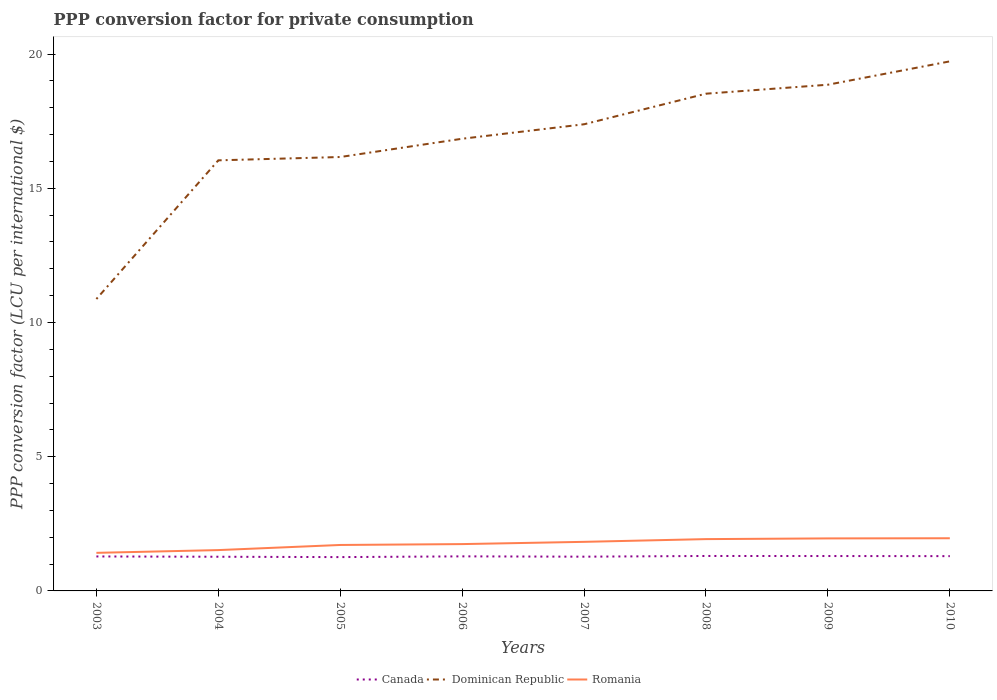How many different coloured lines are there?
Your response must be concise. 3. Across all years, what is the maximum PPP conversion factor for private consumption in Romania?
Provide a succinct answer. 1.42. What is the total PPP conversion factor for private consumption in Romania in the graph?
Keep it short and to the point. -0.33. What is the difference between the highest and the second highest PPP conversion factor for private consumption in Dominican Republic?
Provide a short and direct response. 8.85. What is the difference between the highest and the lowest PPP conversion factor for private consumption in Romania?
Your response must be concise. 4. What is the difference between two consecutive major ticks on the Y-axis?
Your answer should be compact. 5. Does the graph contain grids?
Ensure brevity in your answer.  No. How many legend labels are there?
Your answer should be very brief. 3. What is the title of the graph?
Make the answer very short. PPP conversion factor for private consumption. What is the label or title of the X-axis?
Provide a succinct answer. Years. What is the label or title of the Y-axis?
Offer a very short reply. PPP conversion factor (LCU per international $). What is the PPP conversion factor (LCU per international $) in Canada in 2003?
Give a very brief answer. 1.28. What is the PPP conversion factor (LCU per international $) in Dominican Republic in 2003?
Your answer should be compact. 10.87. What is the PPP conversion factor (LCU per international $) of Romania in 2003?
Ensure brevity in your answer.  1.42. What is the PPP conversion factor (LCU per international $) in Canada in 2004?
Your answer should be very brief. 1.27. What is the PPP conversion factor (LCU per international $) of Dominican Republic in 2004?
Ensure brevity in your answer.  16.04. What is the PPP conversion factor (LCU per international $) in Romania in 2004?
Provide a short and direct response. 1.52. What is the PPP conversion factor (LCU per international $) in Canada in 2005?
Your answer should be very brief. 1.26. What is the PPP conversion factor (LCU per international $) in Dominican Republic in 2005?
Your response must be concise. 16.16. What is the PPP conversion factor (LCU per international $) in Romania in 2005?
Give a very brief answer. 1.71. What is the PPP conversion factor (LCU per international $) in Canada in 2006?
Make the answer very short. 1.29. What is the PPP conversion factor (LCU per international $) in Dominican Republic in 2006?
Your answer should be compact. 16.84. What is the PPP conversion factor (LCU per international $) of Romania in 2006?
Offer a terse response. 1.74. What is the PPP conversion factor (LCU per international $) in Canada in 2007?
Offer a terse response. 1.28. What is the PPP conversion factor (LCU per international $) in Dominican Republic in 2007?
Give a very brief answer. 17.38. What is the PPP conversion factor (LCU per international $) of Romania in 2007?
Your answer should be compact. 1.83. What is the PPP conversion factor (LCU per international $) of Canada in 2008?
Your answer should be compact. 1.3. What is the PPP conversion factor (LCU per international $) of Dominican Republic in 2008?
Offer a terse response. 18.52. What is the PPP conversion factor (LCU per international $) in Romania in 2008?
Ensure brevity in your answer.  1.93. What is the PPP conversion factor (LCU per international $) in Canada in 2009?
Provide a succinct answer. 1.3. What is the PPP conversion factor (LCU per international $) in Dominican Republic in 2009?
Give a very brief answer. 18.86. What is the PPP conversion factor (LCU per international $) of Romania in 2009?
Your answer should be very brief. 1.96. What is the PPP conversion factor (LCU per international $) of Canada in 2010?
Keep it short and to the point. 1.3. What is the PPP conversion factor (LCU per international $) of Dominican Republic in 2010?
Give a very brief answer. 19.73. What is the PPP conversion factor (LCU per international $) in Romania in 2010?
Offer a terse response. 1.96. Across all years, what is the maximum PPP conversion factor (LCU per international $) of Canada?
Offer a terse response. 1.3. Across all years, what is the maximum PPP conversion factor (LCU per international $) of Dominican Republic?
Your response must be concise. 19.73. Across all years, what is the maximum PPP conversion factor (LCU per international $) in Romania?
Give a very brief answer. 1.96. Across all years, what is the minimum PPP conversion factor (LCU per international $) of Canada?
Your answer should be very brief. 1.26. Across all years, what is the minimum PPP conversion factor (LCU per international $) in Dominican Republic?
Keep it short and to the point. 10.87. Across all years, what is the minimum PPP conversion factor (LCU per international $) of Romania?
Your answer should be very brief. 1.42. What is the total PPP conversion factor (LCU per international $) in Canada in the graph?
Provide a succinct answer. 10.28. What is the total PPP conversion factor (LCU per international $) of Dominican Republic in the graph?
Provide a short and direct response. 134.41. What is the total PPP conversion factor (LCU per international $) in Romania in the graph?
Offer a very short reply. 14.07. What is the difference between the PPP conversion factor (LCU per international $) of Canada in 2003 and that in 2004?
Your answer should be compact. 0.01. What is the difference between the PPP conversion factor (LCU per international $) in Dominican Republic in 2003 and that in 2004?
Provide a succinct answer. -5.17. What is the difference between the PPP conversion factor (LCU per international $) in Romania in 2003 and that in 2004?
Your answer should be very brief. -0.1. What is the difference between the PPP conversion factor (LCU per international $) in Canada in 2003 and that in 2005?
Give a very brief answer. 0.02. What is the difference between the PPP conversion factor (LCU per international $) of Dominican Republic in 2003 and that in 2005?
Offer a terse response. -5.29. What is the difference between the PPP conversion factor (LCU per international $) of Romania in 2003 and that in 2005?
Give a very brief answer. -0.29. What is the difference between the PPP conversion factor (LCU per international $) of Canada in 2003 and that in 2006?
Ensure brevity in your answer.  -0. What is the difference between the PPP conversion factor (LCU per international $) in Dominican Republic in 2003 and that in 2006?
Make the answer very short. -5.97. What is the difference between the PPP conversion factor (LCU per international $) of Romania in 2003 and that in 2006?
Offer a very short reply. -0.33. What is the difference between the PPP conversion factor (LCU per international $) in Canada in 2003 and that in 2007?
Provide a short and direct response. 0.01. What is the difference between the PPP conversion factor (LCU per international $) in Dominican Republic in 2003 and that in 2007?
Offer a terse response. -6.51. What is the difference between the PPP conversion factor (LCU per international $) in Romania in 2003 and that in 2007?
Your answer should be very brief. -0.41. What is the difference between the PPP conversion factor (LCU per international $) of Canada in 2003 and that in 2008?
Provide a short and direct response. -0.02. What is the difference between the PPP conversion factor (LCU per international $) of Dominican Republic in 2003 and that in 2008?
Make the answer very short. -7.65. What is the difference between the PPP conversion factor (LCU per international $) in Romania in 2003 and that in 2008?
Offer a very short reply. -0.51. What is the difference between the PPP conversion factor (LCU per international $) of Canada in 2003 and that in 2009?
Provide a succinct answer. -0.02. What is the difference between the PPP conversion factor (LCU per international $) in Dominican Republic in 2003 and that in 2009?
Keep it short and to the point. -7.98. What is the difference between the PPP conversion factor (LCU per international $) of Romania in 2003 and that in 2009?
Offer a terse response. -0.54. What is the difference between the PPP conversion factor (LCU per international $) in Canada in 2003 and that in 2010?
Your response must be concise. -0.01. What is the difference between the PPP conversion factor (LCU per international $) of Dominican Republic in 2003 and that in 2010?
Offer a terse response. -8.85. What is the difference between the PPP conversion factor (LCU per international $) of Romania in 2003 and that in 2010?
Offer a terse response. -0.54. What is the difference between the PPP conversion factor (LCU per international $) of Canada in 2004 and that in 2005?
Your answer should be very brief. 0.01. What is the difference between the PPP conversion factor (LCU per international $) of Dominican Republic in 2004 and that in 2005?
Your answer should be very brief. -0.12. What is the difference between the PPP conversion factor (LCU per international $) of Romania in 2004 and that in 2005?
Offer a terse response. -0.19. What is the difference between the PPP conversion factor (LCU per international $) in Canada in 2004 and that in 2006?
Your answer should be very brief. -0.01. What is the difference between the PPP conversion factor (LCU per international $) of Dominican Republic in 2004 and that in 2006?
Offer a terse response. -0.8. What is the difference between the PPP conversion factor (LCU per international $) in Romania in 2004 and that in 2006?
Provide a succinct answer. -0.22. What is the difference between the PPP conversion factor (LCU per international $) of Canada in 2004 and that in 2007?
Give a very brief answer. -0. What is the difference between the PPP conversion factor (LCU per international $) in Dominican Republic in 2004 and that in 2007?
Make the answer very short. -1.34. What is the difference between the PPP conversion factor (LCU per international $) in Romania in 2004 and that in 2007?
Your answer should be very brief. -0.31. What is the difference between the PPP conversion factor (LCU per international $) in Canada in 2004 and that in 2008?
Ensure brevity in your answer.  -0.03. What is the difference between the PPP conversion factor (LCU per international $) of Dominican Republic in 2004 and that in 2008?
Provide a succinct answer. -2.48. What is the difference between the PPP conversion factor (LCU per international $) in Romania in 2004 and that in 2008?
Provide a short and direct response. -0.41. What is the difference between the PPP conversion factor (LCU per international $) of Canada in 2004 and that in 2009?
Your answer should be very brief. -0.03. What is the difference between the PPP conversion factor (LCU per international $) of Dominican Republic in 2004 and that in 2009?
Provide a short and direct response. -2.82. What is the difference between the PPP conversion factor (LCU per international $) of Romania in 2004 and that in 2009?
Provide a succinct answer. -0.44. What is the difference between the PPP conversion factor (LCU per international $) in Canada in 2004 and that in 2010?
Make the answer very short. -0.02. What is the difference between the PPP conversion factor (LCU per international $) in Dominican Republic in 2004 and that in 2010?
Offer a terse response. -3.69. What is the difference between the PPP conversion factor (LCU per international $) in Romania in 2004 and that in 2010?
Offer a very short reply. -0.44. What is the difference between the PPP conversion factor (LCU per international $) in Canada in 2005 and that in 2006?
Your response must be concise. -0.03. What is the difference between the PPP conversion factor (LCU per international $) in Dominican Republic in 2005 and that in 2006?
Offer a very short reply. -0.68. What is the difference between the PPP conversion factor (LCU per international $) in Romania in 2005 and that in 2006?
Your answer should be very brief. -0.03. What is the difference between the PPP conversion factor (LCU per international $) in Canada in 2005 and that in 2007?
Keep it short and to the point. -0.02. What is the difference between the PPP conversion factor (LCU per international $) of Dominican Republic in 2005 and that in 2007?
Provide a short and direct response. -1.22. What is the difference between the PPP conversion factor (LCU per international $) in Romania in 2005 and that in 2007?
Provide a short and direct response. -0.12. What is the difference between the PPP conversion factor (LCU per international $) in Canada in 2005 and that in 2008?
Ensure brevity in your answer.  -0.04. What is the difference between the PPP conversion factor (LCU per international $) in Dominican Republic in 2005 and that in 2008?
Offer a terse response. -2.36. What is the difference between the PPP conversion factor (LCU per international $) in Romania in 2005 and that in 2008?
Make the answer very short. -0.22. What is the difference between the PPP conversion factor (LCU per international $) in Canada in 2005 and that in 2009?
Your answer should be compact. -0.04. What is the difference between the PPP conversion factor (LCU per international $) of Dominican Republic in 2005 and that in 2009?
Keep it short and to the point. -2.69. What is the difference between the PPP conversion factor (LCU per international $) of Romania in 2005 and that in 2009?
Your answer should be very brief. -0.24. What is the difference between the PPP conversion factor (LCU per international $) in Canada in 2005 and that in 2010?
Your answer should be compact. -0.04. What is the difference between the PPP conversion factor (LCU per international $) in Dominican Republic in 2005 and that in 2010?
Your response must be concise. -3.56. What is the difference between the PPP conversion factor (LCU per international $) in Romania in 2005 and that in 2010?
Your answer should be compact. -0.25. What is the difference between the PPP conversion factor (LCU per international $) in Canada in 2006 and that in 2007?
Your answer should be very brief. 0.01. What is the difference between the PPP conversion factor (LCU per international $) of Dominican Republic in 2006 and that in 2007?
Your response must be concise. -0.54. What is the difference between the PPP conversion factor (LCU per international $) in Romania in 2006 and that in 2007?
Ensure brevity in your answer.  -0.08. What is the difference between the PPP conversion factor (LCU per international $) in Canada in 2006 and that in 2008?
Make the answer very short. -0.01. What is the difference between the PPP conversion factor (LCU per international $) in Dominican Republic in 2006 and that in 2008?
Provide a succinct answer. -1.68. What is the difference between the PPP conversion factor (LCU per international $) in Romania in 2006 and that in 2008?
Make the answer very short. -0.19. What is the difference between the PPP conversion factor (LCU per international $) of Canada in 2006 and that in 2009?
Give a very brief answer. -0.01. What is the difference between the PPP conversion factor (LCU per international $) in Dominican Republic in 2006 and that in 2009?
Provide a succinct answer. -2.01. What is the difference between the PPP conversion factor (LCU per international $) in Romania in 2006 and that in 2009?
Offer a very short reply. -0.21. What is the difference between the PPP conversion factor (LCU per international $) of Canada in 2006 and that in 2010?
Ensure brevity in your answer.  -0.01. What is the difference between the PPP conversion factor (LCU per international $) in Dominican Republic in 2006 and that in 2010?
Your answer should be compact. -2.88. What is the difference between the PPP conversion factor (LCU per international $) in Romania in 2006 and that in 2010?
Offer a very short reply. -0.22. What is the difference between the PPP conversion factor (LCU per international $) of Canada in 2007 and that in 2008?
Your response must be concise. -0.03. What is the difference between the PPP conversion factor (LCU per international $) in Dominican Republic in 2007 and that in 2008?
Your answer should be compact. -1.14. What is the difference between the PPP conversion factor (LCU per international $) in Romania in 2007 and that in 2008?
Provide a succinct answer. -0.1. What is the difference between the PPP conversion factor (LCU per international $) of Canada in 2007 and that in 2009?
Give a very brief answer. -0.02. What is the difference between the PPP conversion factor (LCU per international $) of Dominican Republic in 2007 and that in 2009?
Your response must be concise. -1.47. What is the difference between the PPP conversion factor (LCU per international $) of Romania in 2007 and that in 2009?
Your response must be concise. -0.13. What is the difference between the PPP conversion factor (LCU per international $) of Canada in 2007 and that in 2010?
Your response must be concise. -0.02. What is the difference between the PPP conversion factor (LCU per international $) in Dominican Republic in 2007 and that in 2010?
Provide a short and direct response. -2.34. What is the difference between the PPP conversion factor (LCU per international $) of Romania in 2007 and that in 2010?
Keep it short and to the point. -0.13. What is the difference between the PPP conversion factor (LCU per international $) of Canada in 2008 and that in 2009?
Keep it short and to the point. 0. What is the difference between the PPP conversion factor (LCU per international $) of Dominican Republic in 2008 and that in 2009?
Give a very brief answer. -0.33. What is the difference between the PPP conversion factor (LCU per international $) of Romania in 2008 and that in 2009?
Offer a terse response. -0.03. What is the difference between the PPP conversion factor (LCU per international $) in Canada in 2008 and that in 2010?
Provide a short and direct response. 0.01. What is the difference between the PPP conversion factor (LCU per international $) of Dominican Republic in 2008 and that in 2010?
Offer a very short reply. -1.2. What is the difference between the PPP conversion factor (LCU per international $) in Romania in 2008 and that in 2010?
Make the answer very short. -0.03. What is the difference between the PPP conversion factor (LCU per international $) of Canada in 2009 and that in 2010?
Provide a short and direct response. 0. What is the difference between the PPP conversion factor (LCU per international $) in Dominican Republic in 2009 and that in 2010?
Keep it short and to the point. -0.87. What is the difference between the PPP conversion factor (LCU per international $) of Romania in 2009 and that in 2010?
Keep it short and to the point. -0.01. What is the difference between the PPP conversion factor (LCU per international $) of Canada in 2003 and the PPP conversion factor (LCU per international $) of Dominican Republic in 2004?
Keep it short and to the point. -14.76. What is the difference between the PPP conversion factor (LCU per international $) of Canada in 2003 and the PPP conversion factor (LCU per international $) of Romania in 2004?
Provide a short and direct response. -0.24. What is the difference between the PPP conversion factor (LCU per international $) of Dominican Republic in 2003 and the PPP conversion factor (LCU per international $) of Romania in 2004?
Keep it short and to the point. 9.35. What is the difference between the PPP conversion factor (LCU per international $) of Canada in 2003 and the PPP conversion factor (LCU per international $) of Dominican Republic in 2005?
Your response must be concise. -14.88. What is the difference between the PPP conversion factor (LCU per international $) in Canada in 2003 and the PPP conversion factor (LCU per international $) in Romania in 2005?
Provide a short and direct response. -0.43. What is the difference between the PPP conversion factor (LCU per international $) of Dominican Republic in 2003 and the PPP conversion factor (LCU per international $) of Romania in 2005?
Make the answer very short. 9.16. What is the difference between the PPP conversion factor (LCU per international $) in Canada in 2003 and the PPP conversion factor (LCU per international $) in Dominican Republic in 2006?
Provide a succinct answer. -15.56. What is the difference between the PPP conversion factor (LCU per international $) of Canada in 2003 and the PPP conversion factor (LCU per international $) of Romania in 2006?
Keep it short and to the point. -0.46. What is the difference between the PPP conversion factor (LCU per international $) in Dominican Republic in 2003 and the PPP conversion factor (LCU per international $) in Romania in 2006?
Give a very brief answer. 9.13. What is the difference between the PPP conversion factor (LCU per international $) in Canada in 2003 and the PPP conversion factor (LCU per international $) in Dominican Republic in 2007?
Give a very brief answer. -16.1. What is the difference between the PPP conversion factor (LCU per international $) in Canada in 2003 and the PPP conversion factor (LCU per international $) in Romania in 2007?
Your response must be concise. -0.54. What is the difference between the PPP conversion factor (LCU per international $) in Dominican Republic in 2003 and the PPP conversion factor (LCU per international $) in Romania in 2007?
Provide a short and direct response. 9.05. What is the difference between the PPP conversion factor (LCU per international $) in Canada in 2003 and the PPP conversion factor (LCU per international $) in Dominican Republic in 2008?
Ensure brevity in your answer.  -17.24. What is the difference between the PPP conversion factor (LCU per international $) in Canada in 2003 and the PPP conversion factor (LCU per international $) in Romania in 2008?
Your answer should be compact. -0.65. What is the difference between the PPP conversion factor (LCU per international $) in Dominican Republic in 2003 and the PPP conversion factor (LCU per international $) in Romania in 2008?
Offer a very short reply. 8.94. What is the difference between the PPP conversion factor (LCU per international $) in Canada in 2003 and the PPP conversion factor (LCU per international $) in Dominican Republic in 2009?
Give a very brief answer. -17.57. What is the difference between the PPP conversion factor (LCU per international $) in Canada in 2003 and the PPP conversion factor (LCU per international $) in Romania in 2009?
Ensure brevity in your answer.  -0.67. What is the difference between the PPP conversion factor (LCU per international $) in Dominican Republic in 2003 and the PPP conversion factor (LCU per international $) in Romania in 2009?
Offer a very short reply. 8.92. What is the difference between the PPP conversion factor (LCU per international $) in Canada in 2003 and the PPP conversion factor (LCU per international $) in Dominican Republic in 2010?
Provide a short and direct response. -18.44. What is the difference between the PPP conversion factor (LCU per international $) in Canada in 2003 and the PPP conversion factor (LCU per international $) in Romania in 2010?
Offer a very short reply. -0.68. What is the difference between the PPP conversion factor (LCU per international $) in Dominican Republic in 2003 and the PPP conversion factor (LCU per international $) in Romania in 2010?
Your response must be concise. 8.91. What is the difference between the PPP conversion factor (LCU per international $) in Canada in 2004 and the PPP conversion factor (LCU per international $) in Dominican Republic in 2005?
Provide a short and direct response. -14.89. What is the difference between the PPP conversion factor (LCU per international $) of Canada in 2004 and the PPP conversion factor (LCU per international $) of Romania in 2005?
Ensure brevity in your answer.  -0.44. What is the difference between the PPP conversion factor (LCU per international $) of Dominican Republic in 2004 and the PPP conversion factor (LCU per international $) of Romania in 2005?
Make the answer very short. 14.33. What is the difference between the PPP conversion factor (LCU per international $) in Canada in 2004 and the PPP conversion factor (LCU per international $) in Dominican Republic in 2006?
Your answer should be very brief. -15.57. What is the difference between the PPP conversion factor (LCU per international $) in Canada in 2004 and the PPP conversion factor (LCU per international $) in Romania in 2006?
Keep it short and to the point. -0.47. What is the difference between the PPP conversion factor (LCU per international $) in Dominican Republic in 2004 and the PPP conversion factor (LCU per international $) in Romania in 2006?
Your response must be concise. 14.3. What is the difference between the PPP conversion factor (LCU per international $) of Canada in 2004 and the PPP conversion factor (LCU per international $) of Dominican Republic in 2007?
Your response must be concise. -16.11. What is the difference between the PPP conversion factor (LCU per international $) of Canada in 2004 and the PPP conversion factor (LCU per international $) of Romania in 2007?
Your response must be concise. -0.55. What is the difference between the PPP conversion factor (LCU per international $) of Dominican Republic in 2004 and the PPP conversion factor (LCU per international $) of Romania in 2007?
Give a very brief answer. 14.21. What is the difference between the PPP conversion factor (LCU per international $) in Canada in 2004 and the PPP conversion factor (LCU per international $) in Dominican Republic in 2008?
Keep it short and to the point. -17.25. What is the difference between the PPP conversion factor (LCU per international $) in Canada in 2004 and the PPP conversion factor (LCU per international $) in Romania in 2008?
Your answer should be very brief. -0.66. What is the difference between the PPP conversion factor (LCU per international $) in Dominican Republic in 2004 and the PPP conversion factor (LCU per international $) in Romania in 2008?
Your response must be concise. 14.11. What is the difference between the PPP conversion factor (LCU per international $) of Canada in 2004 and the PPP conversion factor (LCU per international $) of Dominican Republic in 2009?
Provide a short and direct response. -17.58. What is the difference between the PPP conversion factor (LCU per international $) in Canada in 2004 and the PPP conversion factor (LCU per international $) in Romania in 2009?
Provide a short and direct response. -0.68. What is the difference between the PPP conversion factor (LCU per international $) in Dominican Republic in 2004 and the PPP conversion factor (LCU per international $) in Romania in 2009?
Provide a succinct answer. 14.08. What is the difference between the PPP conversion factor (LCU per international $) in Canada in 2004 and the PPP conversion factor (LCU per international $) in Dominican Republic in 2010?
Your answer should be very brief. -18.45. What is the difference between the PPP conversion factor (LCU per international $) of Canada in 2004 and the PPP conversion factor (LCU per international $) of Romania in 2010?
Your response must be concise. -0.69. What is the difference between the PPP conversion factor (LCU per international $) of Dominican Republic in 2004 and the PPP conversion factor (LCU per international $) of Romania in 2010?
Give a very brief answer. 14.08. What is the difference between the PPP conversion factor (LCU per international $) in Canada in 2005 and the PPP conversion factor (LCU per international $) in Dominican Republic in 2006?
Offer a very short reply. -15.58. What is the difference between the PPP conversion factor (LCU per international $) of Canada in 2005 and the PPP conversion factor (LCU per international $) of Romania in 2006?
Offer a very short reply. -0.48. What is the difference between the PPP conversion factor (LCU per international $) of Dominican Republic in 2005 and the PPP conversion factor (LCU per international $) of Romania in 2006?
Keep it short and to the point. 14.42. What is the difference between the PPP conversion factor (LCU per international $) in Canada in 2005 and the PPP conversion factor (LCU per international $) in Dominican Republic in 2007?
Your answer should be compact. -16.12. What is the difference between the PPP conversion factor (LCU per international $) of Canada in 2005 and the PPP conversion factor (LCU per international $) of Romania in 2007?
Give a very brief answer. -0.57. What is the difference between the PPP conversion factor (LCU per international $) in Dominican Republic in 2005 and the PPP conversion factor (LCU per international $) in Romania in 2007?
Provide a short and direct response. 14.34. What is the difference between the PPP conversion factor (LCU per international $) in Canada in 2005 and the PPP conversion factor (LCU per international $) in Dominican Republic in 2008?
Offer a terse response. -17.26. What is the difference between the PPP conversion factor (LCU per international $) of Canada in 2005 and the PPP conversion factor (LCU per international $) of Romania in 2008?
Give a very brief answer. -0.67. What is the difference between the PPP conversion factor (LCU per international $) of Dominican Republic in 2005 and the PPP conversion factor (LCU per international $) of Romania in 2008?
Your answer should be very brief. 14.23. What is the difference between the PPP conversion factor (LCU per international $) of Canada in 2005 and the PPP conversion factor (LCU per international $) of Dominican Republic in 2009?
Ensure brevity in your answer.  -17.6. What is the difference between the PPP conversion factor (LCU per international $) in Canada in 2005 and the PPP conversion factor (LCU per international $) in Romania in 2009?
Your answer should be compact. -0.7. What is the difference between the PPP conversion factor (LCU per international $) in Dominican Republic in 2005 and the PPP conversion factor (LCU per international $) in Romania in 2009?
Your answer should be compact. 14.21. What is the difference between the PPP conversion factor (LCU per international $) in Canada in 2005 and the PPP conversion factor (LCU per international $) in Dominican Republic in 2010?
Your response must be concise. -18.47. What is the difference between the PPP conversion factor (LCU per international $) in Canada in 2005 and the PPP conversion factor (LCU per international $) in Romania in 2010?
Offer a terse response. -0.7. What is the difference between the PPP conversion factor (LCU per international $) of Dominican Republic in 2005 and the PPP conversion factor (LCU per international $) of Romania in 2010?
Provide a short and direct response. 14.2. What is the difference between the PPP conversion factor (LCU per international $) in Canada in 2006 and the PPP conversion factor (LCU per international $) in Dominican Republic in 2007?
Your answer should be very brief. -16.1. What is the difference between the PPP conversion factor (LCU per international $) in Canada in 2006 and the PPP conversion factor (LCU per international $) in Romania in 2007?
Provide a short and direct response. -0.54. What is the difference between the PPP conversion factor (LCU per international $) of Dominican Republic in 2006 and the PPP conversion factor (LCU per international $) of Romania in 2007?
Make the answer very short. 15.02. What is the difference between the PPP conversion factor (LCU per international $) of Canada in 2006 and the PPP conversion factor (LCU per international $) of Dominican Republic in 2008?
Make the answer very short. -17.24. What is the difference between the PPP conversion factor (LCU per international $) of Canada in 2006 and the PPP conversion factor (LCU per international $) of Romania in 2008?
Offer a terse response. -0.64. What is the difference between the PPP conversion factor (LCU per international $) in Dominican Republic in 2006 and the PPP conversion factor (LCU per international $) in Romania in 2008?
Your response must be concise. 14.91. What is the difference between the PPP conversion factor (LCU per international $) of Canada in 2006 and the PPP conversion factor (LCU per international $) of Dominican Republic in 2009?
Make the answer very short. -17.57. What is the difference between the PPP conversion factor (LCU per international $) in Canada in 2006 and the PPP conversion factor (LCU per international $) in Romania in 2009?
Provide a short and direct response. -0.67. What is the difference between the PPP conversion factor (LCU per international $) of Dominican Republic in 2006 and the PPP conversion factor (LCU per international $) of Romania in 2009?
Provide a succinct answer. 14.89. What is the difference between the PPP conversion factor (LCU per international $) in Canada in 2006 and the PPP conversion factor (LCU per international $) in Dominican Republic in 2010?
Provide a succinct answer. -18.44. What is the difference between the PPP conversion factor (LCU per international $) in Canada in 2006 and the PPP conversion factor (LCU per international $) in Romania in 2010?
Give a very brief answer. -0.67. What is the difference between the PPP conversion factor (LCU per international $) in Dominican Republic in 2006 and the PPP conversion factor (LCU per international $) in Romania in 2010?
Ensure brevity in your answer.  14.88. What is the difference between the PPP conversion factor (LCU per international $) of Canada in 2007 and the PPP conversion factor (LCU per international $) of Dominican Republic in 2008?
Your answer should be compact. -17.25. What is the difference between the PPP conversion factor (LCU per international $) in Canada in 2007 and the PPP conversion factor (LCU per international $) in Romania in 2008?
Your response must be concise. -0.65. What is the difference between the PPP conversion factor (LCU per international $) of Dominican Republic in 2007 and the PPP conversion factor (LCU per international $) of Romania in 2008?
Your response must be concise. 15.45. What is the difference between the PPP conversion factor (LCU per international $) of Canada in 2007 and the PPP conversion factor (LCU per international $) of Dominican Republic in 2009?
Make the answer very short. -17.58. What is the difference between the PPP conversion factor (LCU per international $) of Canada in 2007 and the PPP conversion factor (LCU per international $) of Romania in 2009?
Offer a terse response. -0.68. What is the difference between the PPP conversion factor (LCU per international $) of Dominican Republic in 2007 and the PPP conversion factor (LCU per international $) of Romania in 2009?
Offer a terse response. 15.43. What is the difference between the PPP conversion factor (LCU per international $) in Canada in 2007 and the PPP conversion factor (LCU per international $) in Dominican Republic in 2010?
Provide a succinct answer. -18.45. What is the difference between the PPP conversion factor (LCU per international $) of Canada in 2007 and the PPP conversion factor (LCU per international $) of Romania in 2010?
Your response must be concise. -0.69. What is the difference between the PPP conversion factor (LCU per international $) of Dominican Republic in 2007 and the PPP conversion factor (LCU per international $) of Romania in 2010?
Keep it short and to the point. 15.42. What is the difference between the PPP conversion factor (LCU per international $) in Canada in 2008 and the PPP conversion factor (LCU per international $) in Dominican Republic in 2009?
Your response must be concise. -17.55. What is the difference between the PPP conversion factor (LCU per international $) in Canada in 2008 and the PPP conversion factor (LCU per international $) in Romania in 2009?
Keep it short and to the point. -0.65. What is the difference between the PPP conversion factor (LCU per international $) in Dominican Republic in 2008 and the PPP conversion factor (LCU per international $) in Romania in 2009?
Provide a succinct answer. 16.57. What is the difference between the PPP conversion factor (LCU per international $) in Canada in 2008 and the PPP conversion factor (LCU per international $) in Dominican Republic in 2010?
Your response must be concise. -18.43. What is the difference between the PPP conversion factor (LCU per international $) of Canada in 2008 and the PPP conversion factor (LCU per international $) of Romania in 2010?
Offer a terse response. -0.66. What is the difference between the PPP conversion factor (LCU per international $) of Dominican Republic in 2008 and the PPP conversion factor (LCU per international $) of Romania in 2010?
Make the answer very short. 16.56. What is the difference between the PPP conversion factor (LCU per international $) in Canada in 2009 and the PPP conversion factor (LCU per international $) in Dominican Republic in 2010?
Offer a terse response. -18.43. What is the difference between the PPP conversion factor (LCU per international $) of Canada in 2009 and the PPP conversion factor (LCU per international $) of Romania in 2010?
Offer a very short reply. -0.66. What is the difference between the PPP conversion factor (LCU per international $) in Dominican Republic in 2009 and the PPP conversion factor (LCU per international $) in Romania in 2010?
Your response must be concise. 16.89. What is the average PPP conversion factor (LCU per international $) in Canada per year?
Make the answer very short. 1.28. What is the average PPP conversion factor (LCU per international $) of Dominican Republic per year?
Provide a succinct answer. 16.8. What is the average PPP conversion factor (LCU per international $) in Romania per year?
Keep it short and to the point. 1.76. In the year 2003, what is the difference between the PPP conversion factor (LCU per international $) of Canada and PPP conversion factor (LCU per international $) of Dominican Republic?
Ensure brevity in your answer.  -9.59. In the year 2003, what is the difference between the PPP conversion factor (LCU per international $) of Canada and PPP conversion factor (LCU per international $) of Romania?
Make the answer very short. -0.13. In the year 2003, what is the difference between the PPP conversion factor (LCU per international $) of Dominican Republic and PPP conversion factor (LCU per international $) of Romania?
Give a very brief answer. 9.46. In the year 2004, what is the difference between the PPP conversion factor (LCU per international $) in Canada and PPP conversion factor (LCU per international $) in Dominican Republic?
Make the answer very short. -14.77. In the year 2004, what is the difference between the PPP conversion factor (LCU per international $) of Canada and PPP conversion factor (LCU per international $) of Romania?
Your answer should be very brief. -0.25. In the year 2004, what is the difference between the PPP conversion factor (LCU per international $) of Dominican Republic and PPP conversion factor (LCU per international $) of Romania?
Your answer should be very brief. 14.52. In the year 2005, what is the difference between the PPP conversion factor (LCU per international $) of Canada and PPP conversion factor (LCU per international $) of Dominican Republic?
Offer a very short reply. -14.9. In the year 2005, what is the difference between the PPP conversion factor (LCU per international $) of Canada and PPP conversion factor (LCU per international $) of Romania?
Ensure brevity in your answer.  -0.45. In the year 2005, what is the difference between the PPP conversion factor (LCU per international $) in Dominican Republic and PPP conversion factor (LCU per international $) in Romania?
Offer a very short reply. 14.45. In the year 2006, what is the difference between the PPP conversion factor (LCU per international $) of Canada and PPP conversion factor (LCU per international $) of Dominican Republic?
Provide a succinct answer. -15.56. In the year 2006, what is the difference between the PPP conversion factor (LCU per international $) in Canada and PPP conversion factor (LCU per international $) in Romania?
Provide a short and direct response. -0.46. In the year 2006, what is the difference between the PPP conversion factor (LCU per international $) in Dominican Republic and PPP conversion factor (LCU per international $) in Romania?
Your response must be concise. 15.1. In the year 2007, what is the difference between the PPP conversion factor (LCU per international $) of Canada and PPP conversion factor (LCU per international $) of Dominican Republic?
Your response must be concise. -16.11. In the year 2007, what is the difference between the PPP conversion factor (LCU per international $) of Canada and PPP conversion factor (LCU per international $) of Romania?
Your answer should be compact. -0.55. In the year 2007, what is the difference between the PPP conversion factor (LCU per international $) of Dominican Republic and PPP conversion factor (LCU per international $) of Romania?
Provide a short and direct response. 15.56. In the year 2008, what is the difference between the PPP conversion factor (LCU per international $) of Canada and PPP conversion factor (LCU per international $) of Dominican Republic?
Ensure brevity in your answer.  -17.22. In the year 2008, what is the difference between the PPP conversion factor (LCU per international $) in Canada and PPP conversion factor (LCU per international $) in Romania?
Your answer should be compact. -0.63. In the year 2008, what is the difference between the PPP conversion factor (LCU per international $) of Dominican Republic and PPP conversion factor (LCU per international $) of Romania?
Ensure brevity in your answer.  16.59. In the year 2009, what is the difference between the PPP conversion factor (LCU per international $) of Canada and PPP conversion factor (LCU per international $) of Dominican Republic?
Give a very brief answer. -17.56. In the year 2009, what is the difference between the PPP conversion factor (LCU per international $) in Canada and PPP conversion factor (LCU per international $) in Romania?
Your answer should be compact. -0.66. In the year 2009, what is the difference between the PPP conversion factor (LCU per international $) in Dominican Republic and PPP conversion factor (LCU per international $) in Romania?
Your response must be concise. 16.9. In the year 2010, what is the difference between the PPP conversion factor (LCU per international $) in Canada and PPP conversion factor (LCU per international $) in Dominican Republic?
Keep it short and to the point. -18.43. In the year 2010, what is the difference between the PPP conversion factor (LCU per international $) in Canada and PPP conversion factor (LCU per international $) in Romania?
Provide a short and direct response. -0.67. In the year 2010, what is the difference between the PPP conversion factor (LCU per international $) in Dominican Republic and PPP conversion factor (LCU per international $) in Romania?
Make the answer very short. 17.76. What is the ratio of the PPP conversion factor (LCU per international $) of Canada in 2003 to that in 2004?
Your answer should be compact. 1.01. What is the ratio of the PPP conversion factor (LCU per international $) in Dominican Republic in 2003 to that in 2004?
Make the answer very short. 0.68. What is the ratio of the PPP conversion factor (LCU per international $) in Romania in 2003 to that in 2004?
Offer a very short reply. 0.93. What is the ratio of the PPP conversion factor (LCU per international $) in Canada in 2003 to that in 2005?
Provide a succinct answer. 1.02. What is the ratio of the PPP conversion factor (LCU per international $) of Dominican Republic in 2003 to that in 2005?
Make the answer very short. 0.67. What is the ratio of the PPP conversion factor (LCU per international $) in Romania in 2003 to that in 2005?
Ensure brevity in your answer.  0.83. What is the ratio of the PPP conversion factor (LCU per international $) of Dominican Republic in 2003 to that in 2006?
Provide a short and direct response. 0.65. What is the ratio of the PPP conversion factor (LCU per international $) of Romania in 2003 to that in 2006?
Offer a terse response. 0.81. What is the ratio of the PPP conversion factor (LCU per international $) in Dominican Republic in 2003 to that in 2007?
Provide a short and direct response. 0.63. What is the ratio of the PPP conversion factor (LCU per international $) of Romania in 2003 to that in 2007?
Provide a succinct answer. 0.78. What is the ratio of the PPP conversion factor (LCU per international $) of Canada in 2003 to that in 2008?
Your answer should be compact. 0.99. What is the ratio of the PPP conversion factor (LCU per international $) in Dominican Republic in 2003 to that in 2008?
Keep it short and to the point. 0.59. What is the ratio of the PPP conversion factor (LCU per international $) of Romania in 2003 to that in 2008?
Your answer should be compact. 0.73. What is the ratio of the PPP conversion factor (LCU per international $) of Canada in 2003 to that in 2009?
Ensure brevity in your answer.  0.99. What is the ratio of the PPP conversion factor (LCU per international $) in Dominican Republic in 2003 to that in 2009?
Provide a short and direct response. 0.58. What is the ratio of the PPP conversion factor (LCU per international $) in Romania in 2003 to that in 2009?
Your answer should be very brief. 0.73. What is the ratio of the PPP conversion factor (LCU per international $) of Canada in 2003 to that in 2010?
Provide a succinct answer. 0.99. What is the ratio of the PPP conversion factor (LCU per international $) of Dominican Republic in 2003 to that in 2010?
Provide a succinct answer. 0.55. What is the ratio of the PPP conversion factor (LCU per international $) of Romania in 2003 to that in 2010?
Make the answer very short. 0.72. What is the ratio of the PPP conversion factor (LCU per international $) in Canada in 2004 to that in 2005?
Make the answer very short. 1.01. What is the ratio of the PPP conversion factor (LCU per international $) of Dominican Republic in 2004 to that in 2005?
Make the answer very short. 0.99. What is the ratio of the PPP conversion factor (LCU per international $) in Romania in 2004 to that in 2005?
Your answer should be very brief. 0.89. What is the ratio of the PPP conversion factor (LCU per international $) in Canada in 2004 to that in 2006?
Ensure brevity in your answer.  0.99. What is the ratio of the PPP conversion factor (LCU per international $) of Dominican Republic in 2004 to that in 2006?
Your response must be concise. 0.95. What is the ratio of the PPP conversion factor (LCU per international $) of Romania in 2004 to that in 2006?
Your answer should be very brief. 0.87. What is the ratio of the PPP conversion factor (LCU per international $) of Dominican Republic in 2004 to that in 2007?
Provide a succinct answer. 0.92. What is the ratio of the PPP conversion factor (LCU per international $) of Romania in 2004 to that in 2007?
Offer a terse response. 0.83. What is the ratio of the PPP conversion factor (LCU per international $) of Dominican Republic in 2004 to that in 2008?
Provide a short and direct response. 0.87. What is the ratio of the PPP conversion factor (LCU per international $) in Romania in 2004 to that in 2008?
Your answer should be very brief. 0.79. What is the ratio of the PPP conversion factor (LCU per international $) of Canada in 2004 to that in 2009?
Provide a short and direct response. 0.98. What is the ratio of the PPP conversion factor (LCU per international $) in Dominican Republic in 2004 to that in 2009?
Provide a short and direct response. 0.85. What is the ratio of the PPP conversion factor (LCU per international $) in Romania in 2004 to that in 2009?
Give a very brief answer. 0.78. What is the ratio of the PPP conversion factor (LCU per international $) in Canada in 2004 to that in 2010?
Your response must be concise. 0.98. What is the ratio of the PPP conversion factor (LCU per international $) in Dominican Republic in 2004 to that in 2010?
Keep it short and to the point. 0.81. What is the ratio of the PPP conversion factor (LCU per international $) of Romania in 2004 to that in 2010?
Offer a very short reply. 0.78. What is the ratio of the PPP conversion factor (LCU per international $) in Canada in 2005 to that in 2006?
Ensure brevity in your answer.  0.98. What is the ratio of the PPP conversion factor (LCU per international $) of Dominican Republic in 2005 to that in 2006?
Your answer should be very brief. 0.96. What is the ratio of the PPP conversion factor (LCU per international $) in Romania in 2005 to that in 2006?
Offer a very short reply. 0.98. What is the ratio of the PPP conversion factor (LCU per international $) in Canada in 2005 to that in 2007?
Give a very brief answer. 0.99. What is the ratio of the PPP conversion factor (LCU per international $) in Dominican Republic in 2005 to that in 2007?
Provide a succinct answer. 0.93. What is the ratio of the PPP conversion factor (LCU per international $) of Romania in 2005 to that in 2007?
Give a very brief answer. 0.94. What is the ratio of the PPP conversion factor (LCU per international $) in Canada in 2005 to that in 2008?
Ensure brevity in your answer.  0.97. What is the ratio of the PPP conversion factor (LCU per international $) of Dominican Republic in 2005 to that in 2008?
Keep it short and to the point. 0.87. What is the ratio of the PPP conversion factor (LCU per international $) of Romania in 2005 to that in 2008?
Make the answer very short. 0.89. What is the ratio of the PPP conversion factor (LCU per international $) of Canada in 2005 to that in 2009?
Your answer should be compact. 0.97. What is the ratio of the PPP conversion factor (LCU per international $) of Dominican Republic in 2005 to that in 2009?
Your answer should be very brief. 0.86. What is the ratio of the PPP conversion factor (LCU per international $) of Romania in 2005 to that in 2009?
Keep it short and to the point. 0.88. What is the ratio of the PPP conversion factor (LCU per international $) of Canada in 2005 to that in 2010?
Your answer should be very brief. 0.97. What is the ratio of the PPP conversion factor (LCU per international $) of Dominican Republic in 2005 to that in 2010?
Your response must be concise. 0.82. What is the ratio of the PPP conversion factor (LCU per international $) in Romania in 2005 to that in 2010?
Your response must be concise. 0.87. What is the ratio of the PPP conversion factor (LCU per international $) in Canada in 2006 to that in 2007?
Make the answer very short. 1.01. What is the ratio of the PPP conversion factor (LCU per international $) in Dominican Republic in 2006 to that in 2007?
Your answer should be compact. 0.97. What is the ratio of the PPP conversion factor (LCU per international $) of Romania in 2006 to that in 2007?
Provide a succinct answer. 0.95. What is the ratio of the PPP conversion factor (LCU per international $) of Canada in 2006 to that in 2008?
Keep it short and to the point. 0.99. What is the ratio of the PPP conversion factor (LCU per international $) in Dominican Republic in 2006 to that in 2008?
Your response must be concise. 0.91. What is the ratio of the PPP conversion factor (LCU per international $) of Romania in 2006 to that in 2008?
Provide a succinct answer. 0.9. What is the ratio of the PPP conversion factor (LCU per international $) of Canada in 2006 to that in 2009?
Ensure brevity in your answer.  0.99. What is the ratio of the PPP conversion factor (LCU per international $) of Dominican Republic in 2006 to that in 2009?
Make the answer very short. 0.89. What is the ratio of the PPP conversion factor (LCU per international $) of Romania in 2006 to that in 2009?
Provide a short and direct response. 0.89. What is the ratio of the PPP conversion factor (LCU per international $) of Dominican Republic in 2006 to that in 2010?
Provide a succinct answer. 0.85. What is the ratio of the PPP conversion factor (LCU per international $) in Romania in 2006 to that in 2010?
Ensure brevity in your answer.  0.89. What is the ratio of the PPP conversion factor (LCU per international $) in Canada in 2007 to that in 2008?
Your answer should be compact. 0.98. What is the ratio of the PPP conversion factor (LCU per international $) of Dominican Republic in 2007 to that in 2008?
Your response must be concise. 0.94. What is the ratio of the PPP conversion factor (LCU per international $) of Romania in 2007 to that in 2008?
Provide a short and direct response. 0.95. What is the ratio of the PPP conversion factor (LCU per international $) of Canada in 2007 to that in 2009?
Provide a succinct answer. 0.98. What is the ratio of the PPP conversion factor (LCU per international $) in Dominican Republic in 2007 to that in 2009?
Give a very brief answer. 0.92. What is the ratio of the PPP conversion factor (LCU per international $) of Romania in 2007 to that in 2009?
Your answer should be very brief. 0.93. What is the ratio of the PPP conversion factor (LCU per international $) of Canada in 2007 to that in 2010?
Make the answer very short. 0.98. What is the ratio of the PPP conversion factor (LCU per international $) in Dominican Republic in 2007 to that in 2010?
Offer a terse response. 0.88. What is the ratio of the PPP conversion factor (LCU per international $) in Romania in 2007 to that in 2010?
Offer a terse response. 0.93. What is the ratio of the PPP conversion factor (LCU per international $) of Dominican Republic in 2008 to that in 2009?
Ensure brevity in your answer.  0.98. What is the ratio of the PPP conversion factor (LCU per international $) in Romania in 2008 to that in 2009?
Provide a succinct answer. 0.99. What is the ratio of the PPP conversion factor (LCU per international $) in Canada in 2008 to that in 2010?
Offer a very short reply. 1. What is the ratio of the PPP conversion factor (LCU per international $) of Dominican Republic in 2008 to that in 2010?
Make the answer very short. 0.94. What is the ratio of the PPP conversion factor (LCU per international $) in Romania in 2008 to that in 2010?
Offer a terse response. 0.98. What is the ratio of the PPP conversion factor (LCU per international $) of Dominican Republic in 2009 to that in 2010?
Offer a terse response. 0.96. What is the difference between the highest and the second highest PPP conversion factor (LCU per international $) of Canada?
Make the answer very short. 0. What is the difference between the highest and the second highest PPP conversion factor (LCU per international $) of Dominican Republic?
Make the answer very short. 0.87. What is the difference between the highest and the second highest PPP conversion factor (LCU per international $) in Romania?
Offer a terse response. 0.01. What is the difference between the highest and the lowest PPP conversion factor (LCU per international $) of Canada?
Give a very brief answer. 0.04. What is the difference between the highest and the lowest PPP conversion factor (LCU per international $) in Dominican Republic?
Offer a very short reply. 8.85. What is the difference between the highest and the lowest PPP conversion factor (LCU per international $) of Romania?
Give a very brief answer. 0.54. 